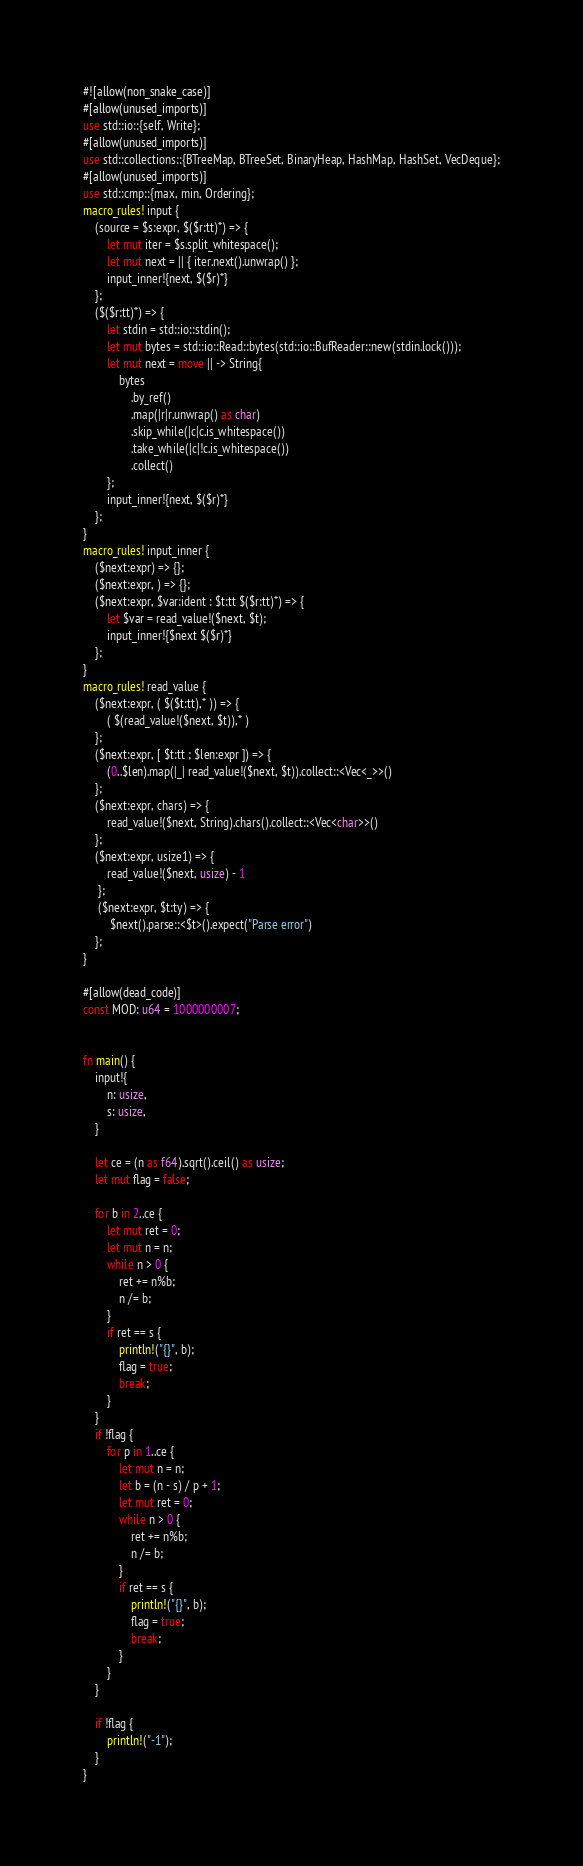Convert code to text. <code><loc_0><loc_0><loc_500><loc_500><_Rust_>#![allow(non_snake_case)]
#[allow(unused_imports)]
use std::io::{self, Write};
#[allow(unused_imports)]
use std::collections::{BTreeMap, BTreeSet, BinaryHeap, HashMap, HashSet, VecDeque};
#[allow(unused_imports)]
use std::cmp::{max, min, Ordering};
macro_rules! input {
    (source = $s:expr, $($r:tt)*) => {
        let mut iter = $s.split_whitespace();
        let mut next = || { iter.next().unwrap() };
        input_inner!{next, $($r)*}
    };
    ($($r:tt)*) => {
        let stdin = std::io::stdin();
        let mut bytes = std::io::Read::bytes(std::io::BufReader::new(stdin.lock()));
        let mut next = move || -> String{
            bytes
                .by_ref()
                .map(|r|r.unwrap() as char)
                .skip_while(|c|c.is_whitespace())
                .take_while(|c|!c.is_whitespace())
                .collect()
        };
        input_inner!{next, $($r)*}
    };
}
macro_rules! input_inner {
    ($next:expr) => {};
    ($next:expr, ) => {};
    ($next:expr, $var:ident : $t:tt $($r:tt)*) => {
        let $var = read_value!($next, $t);
        input_inner!{$next $($r)*}
    };
}
macro_rules! read_value {
    ($next:expr, ( $($t:tt),* )) => {
        ( $(read_value!($next, $t)),* )
    };
    ($next:expr, [ $t:tt ; $len:expr ]) => {
        (0..$len).map(|_| read_value!($next, $t)).collect::<Vec<_>>()
    };
    ($next:expr, chars) => {
        read_value!($next, String).chars().collect::<Vec<char>>()
    };
    ($next:expr, usize1) => {
        read_value!($next, usize) - 1
     };
     ($next:expr, $t:ty) => {
         $next().parse::<$t>().expect("Parse error")
    };
}

#[allow(dead_code)]
const MOD: u64 = 1000000007;


fn main() {
    input!{
        n: usize,
        s: usize,
    }

    let ce = (n as f64).sqrt().ceil() as usize;
    let mut flag = false;

    for b in 2..ce {
        let mut ret = 0;
        let mut n = n;
        while n > 0 {
            ret += n%b;
            n /= b;
        }
        if ret == s {
            println!("{}", b);
            flag = true;
            break;
        }
    }
    if !flag {
        for p in 1..ce {
            let mut n = n;
            let b = (n - s) / p + 1;
            let mut ret = 0;
            while n > 0 {
                ret += n%b;
                n /= b;
            }
            if ret == s {
                println!("{}", b);
                flag = true;
                break;
            }
        }
    }

    if !flag {
        println!("-1");
    }
}</code> 